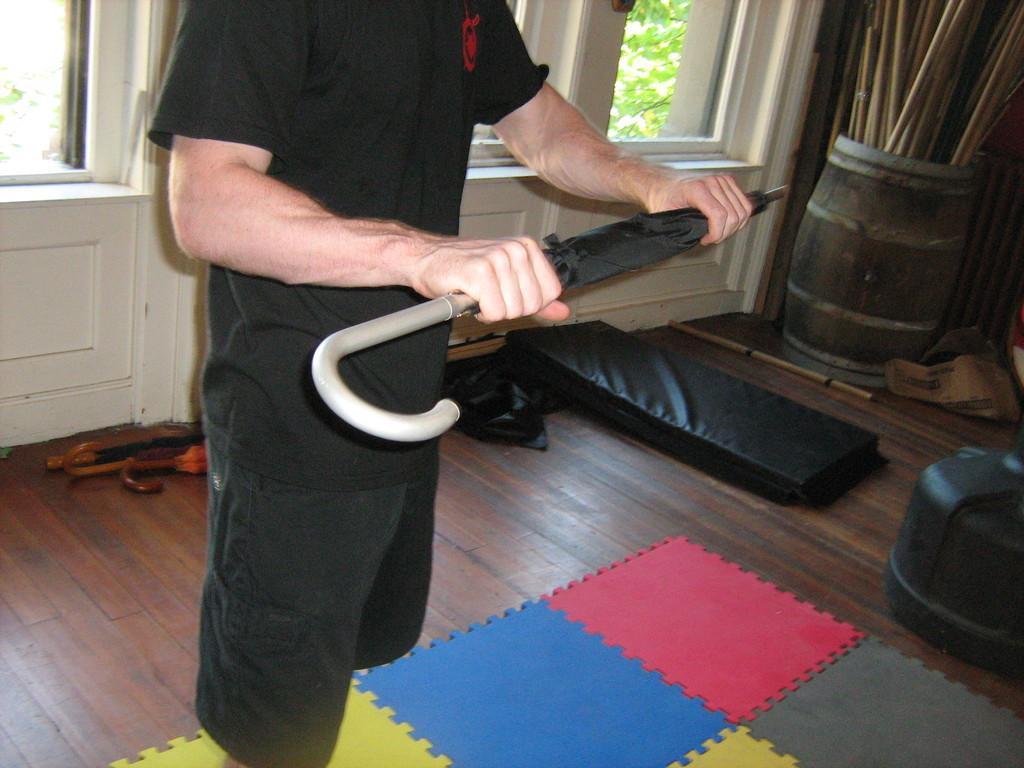Describe this image in one or two sentences. In this picture there is a man wearing a black t-shirt and holding a umbrella in the hand. On the bottom side there is a colorful mat on the wooden flooring. Behind there is a white glass windows. On the right side we can see a drum with many sticks. 